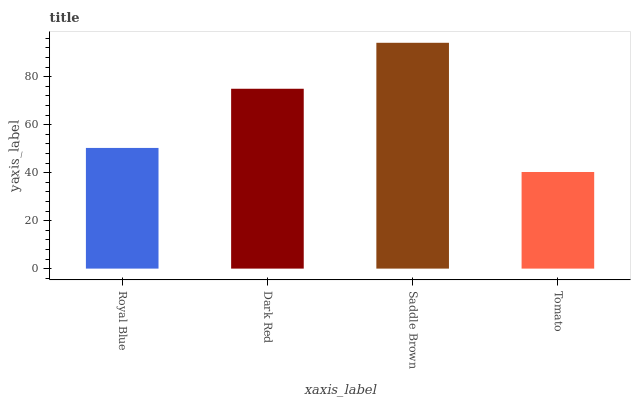Is Tomato the minimum?
Answer yes or no. Yes. Is Saddle Brown the maximum?
Answer yes or no. Yes. Is Dark Red the minimum?
Answer yes or no. No. Is Dark Red the maximum?
Answer yes or no. No. Is Dark Red greater than Royal Blue?
Answer yes or no. Yes. Is Royal Blue less than Dark Red?
Answer yes or no. Yes. Is Royal Blue greater than Dark Red?
Answer yes or no. No. Is Dark Red less than Royal Blue?
Answer yes or no. No. Is Dark Red the high median?
Answer yes or no. Yes. Is Royal Blue the low median?
Answer yes or no. Yes. Is Saddle Brown the high median?
Answer yes or no. No. Is Dark Red the low median?
Answer yes or no. No. 